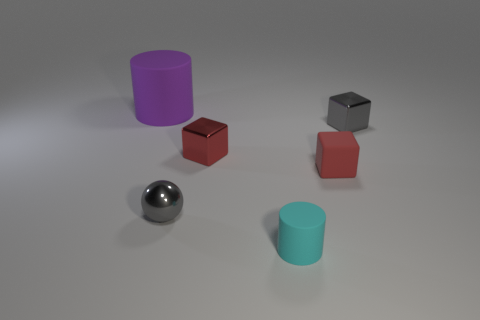Subtract all small red cubes. How many cubes are left? 1 Subtract all gray blocks. How many blocks are left? 2 Add 3 metallic balls. How many objects exist? 9 Subtract 3 cubes. How many cubes are left? 0 Subtract all gray cylinders. Subtract all brown balls. How many cylinders are left? 2 Subtract all green cylinders. How many red cubes are left? 2 Subtract all small red rubber things. Subtract all small green metallic things. How many objects are left? 5 Add 5 cyan matte things. How many cyan matte things are left? 6 Add 3 gray blocks. How many gray blocks exist? 4 Subtract 0 gray cylinders. How many objects are left? 6 